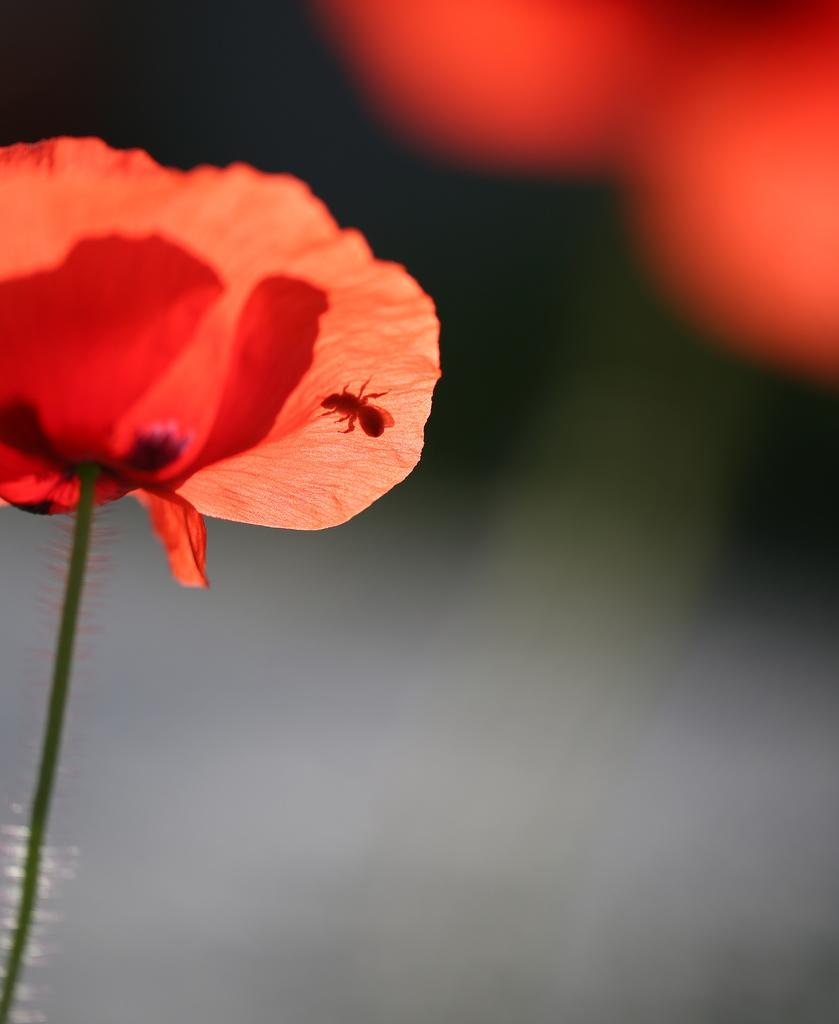What is the main subject of the image? There is a flower in the image. What color is the flower? The flower is red. Are there any other living organisms present in the image? Yes, there is an insect on the flower. What type of knowledge can be gained from the cloth in the image? There is no cloth present in the image, so no knowledge can be gained from it. 